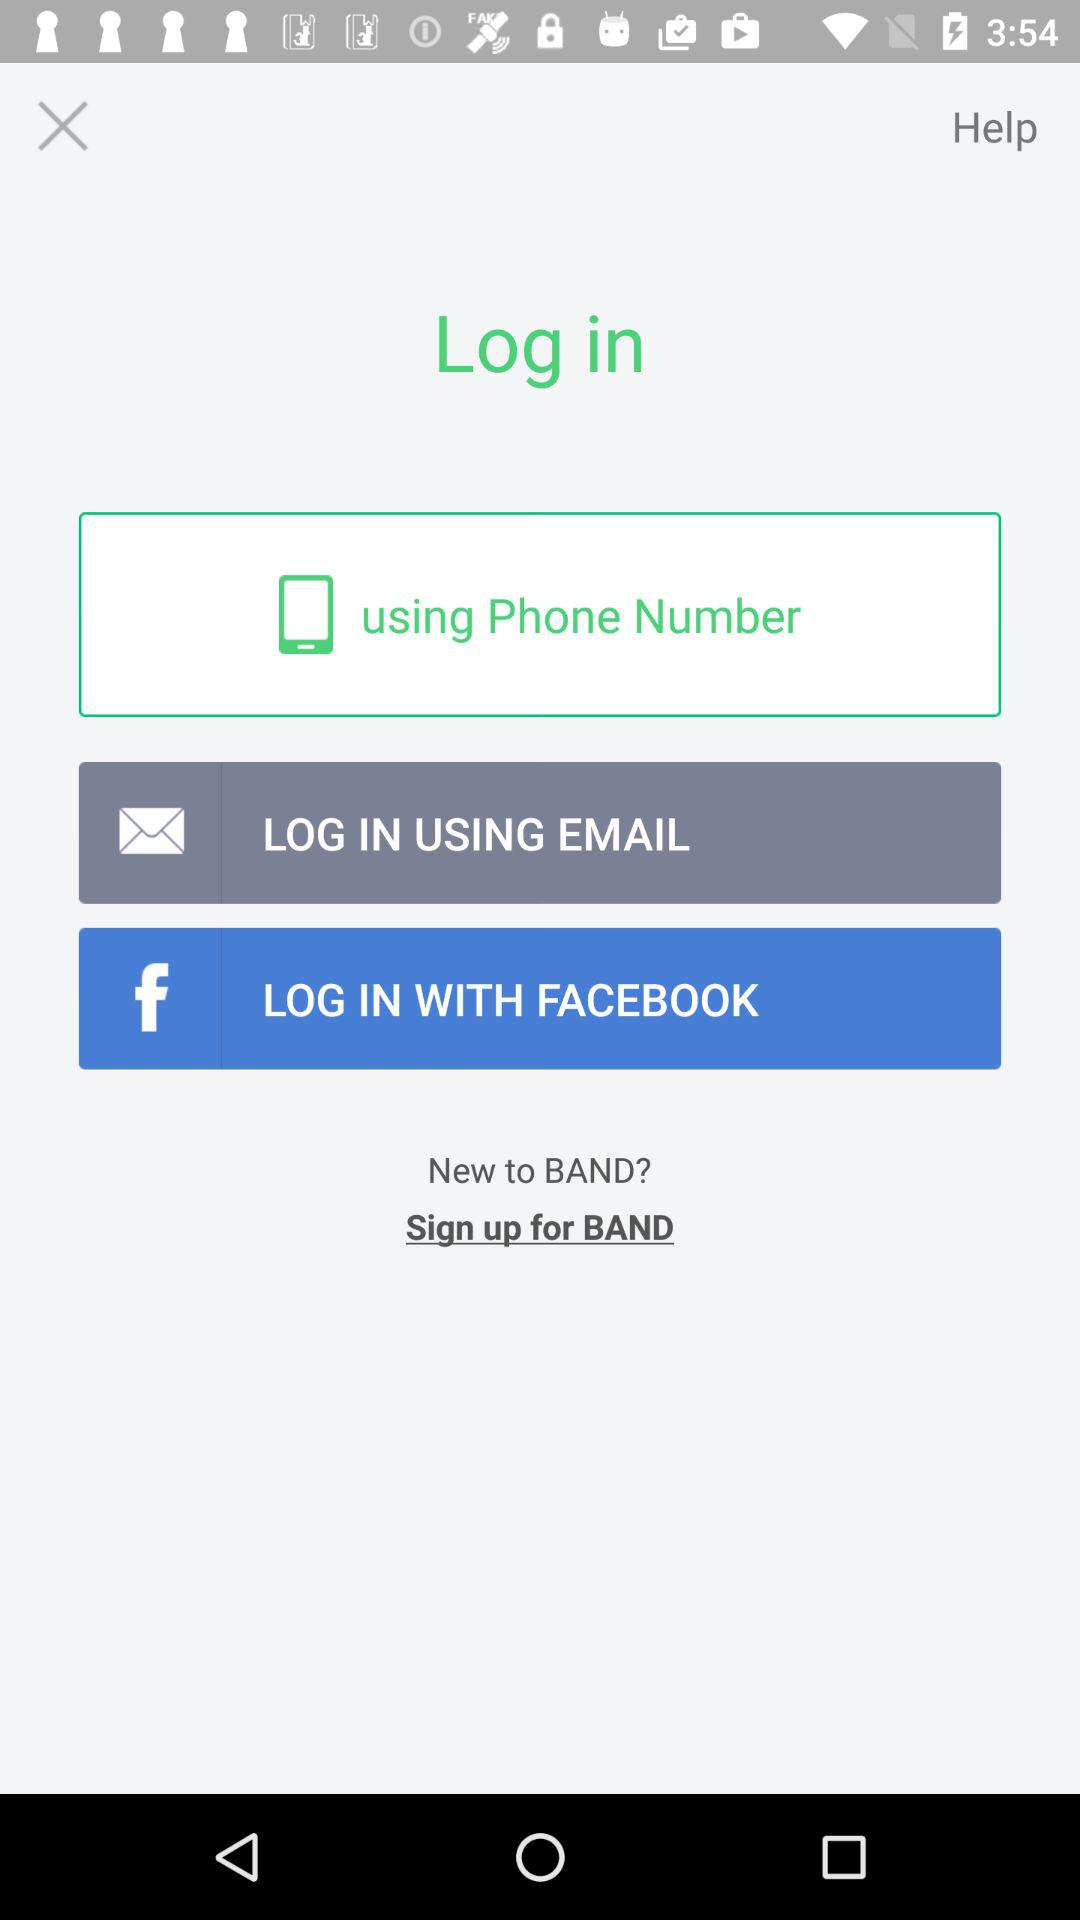How many login options are there?
Answer the question using a single word or phrase. 3 